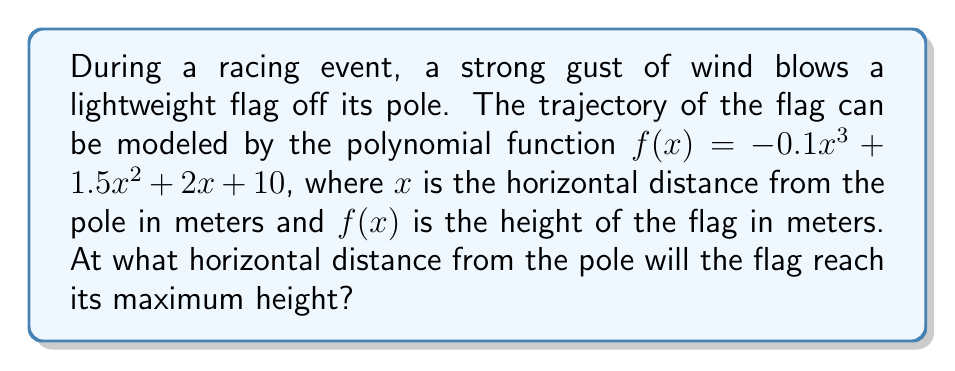Help me with this question. To find the maximum height of the flag's trajectory, we need to determine the x-coordinate of the vertex of the polynomial function. For a cubic function, this occurs at the point where the derivative equals zero.

1. Find the derivative of $f(x)$:
   $f'(x) = -0.3x^2 + 3x + 2$

2. Set the derivative equal to zero and solve for x:
   $-0.3x^2 + 3x + 2 = 0$

3. This is a quadratic equation. We can solve it using the quadratic formula:
   $x = \frac{-b \pm \sqrt{b^2 - 4ac}}{2a}$

   Where $a = -0.3$, $b = 3$, and $c = 2$

4. Substituting these values:
   $x = \frac{-3 \pm \sqrt{3^2 - 4(-0.3)(2)}}{2(-0.3)}$

5. Simplify:
   $x = \frac{-3 \pm \sqrt{9 + 2.4}}{-0.6} = \frac{-3 \pm \sqrt{11.4}}{-0.6}$

6. Calculate the two solutions:
   $x_1 = \frac{-3 + \sqrt{11.4}}{-0.6} \approx 7.37$
   $x_2 = \frac{-3 - \sqrt{11.4}}{-0.6} \approx 2.63$

7. The larger value (7.37) corresponds to the maximum point of the function.

Therefore, the flag will reach its maximum height at approximately 7.37 meters from the pole.
Answer: 7.37 meters 